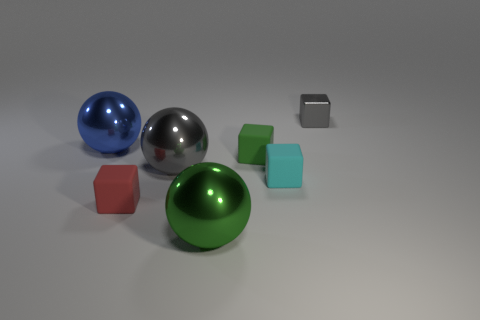There is a small block that is behind the large metal sphere that is behind the large gray thing; what is its color?
Provide a succinct answer. Gray. Is the size of the green matte thing the same as the gray metallic block?
Keep it short and to the point. Yes. There is a shiny sphere in front of the red block; what number of gray things are to the left of it?
Keep it short and to the point. 1. Is the tiny metal thing the same shape as the tiny green matte object?
Keep it short and to the point. Yes. There is a cyan thing that is the same shape as the red object; what size is it?
Your answer should be very brief. Small. What shape is the big metallic thing that is in front of the gray object in front of the blue metal sphere?
Your answer should be compact. Sphere. What is the size of the red matte cube?
Offer a very short reply. Small. What is the shape of the large blue metal object?
Offer a very short reply. Sphere. There is a blue object; is its shape the same as the gray shiny thing that is in front of the small green rubber thing?
Give a very brief answer. Yes. Is the shape of the gray object behind the large gray metallic thing the same as  the cyan matte thing?
Keep it short and to the point. Yes. 